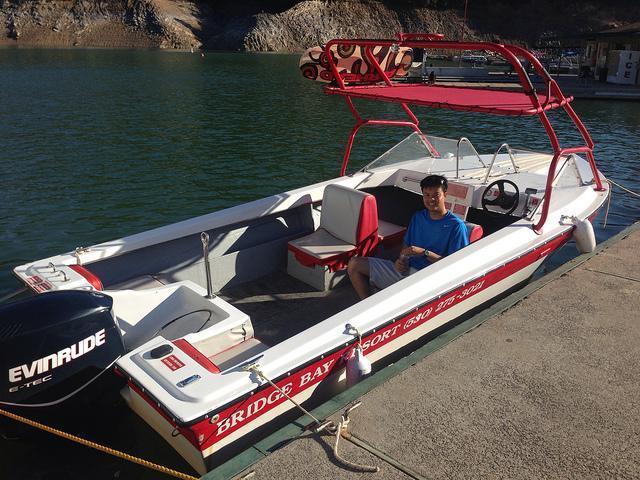Is the statement "The person is on top of the boat." accurate regarding the image?
Answer yes or no. No. 